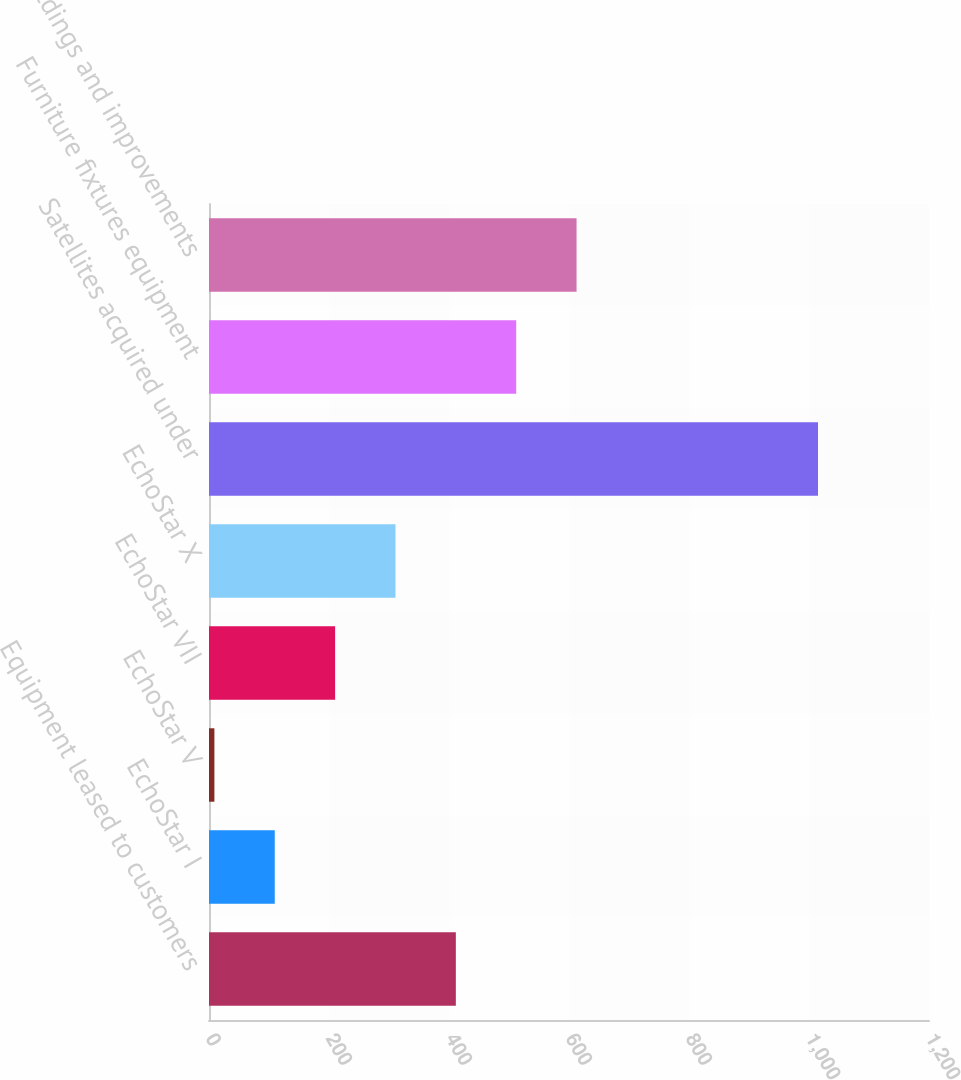Convert chart. <chart><loc_0><loc_0><loc_500><loc_500><bar_chart><fcel>Equipment leased to customers<fcel>EchoStar I<fcel>EchoStar V<fcel>EchoStar VII<fcel>EchoStar X<fcel>Satellites acquired under<fcel>Furniture fixtures equipment<fcel>Buildings and improvements<nl><fcel>411.4<fcel>109.6<fcel>9<fcel>210.2<fcel>310.8<fcel>1015<fcel>512<fcel>612.6<nl></chart> 